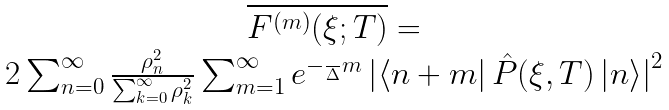<formula> <loc_0><loc_0><loc_500><loc_500>\begin{array} { c } \overline { F ^ { ( m ) } ( \xi ; T ) } = \\ 2 \sum _ { n = 0 } ^ { \infty } \frac { \rho _ { n } ^ { 2 } } { \sum _ { k = 0 } ^ { \infty } \rho _ { k } ^ { 2 } } \sum _ { m = 1 } ^ { \infty } e ^ { - \frac { } { \Delta } m } \left | \langle n + m \right | { \hat { P } } ( \xi , T ) \left | n \rangle \right | ^ { 2 } \end{array}</formula> 